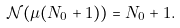<formula> <loc_0><loc_0><loc_500><loc_500>\mathcal { N } ( \mu ( N _ { 0 } + 1 ) ) = N _ { 0 } + 1 .</formula> 